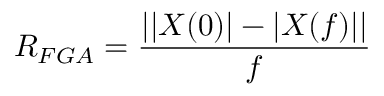Convert formula to latex. <formula><loc_0><loc_0><loc_500><loc_500>R _ { F G A } = \frac { | | X ( 0 ) | - | X ( f ) | | } { f }</formula> 